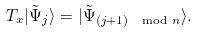Convert formula to latex. <formula><loc_0><loc_0><loc_500><loc_500>T _ { x } | \tilde { \Psi } _ { j } \rangle = | \tilde { \Psi } _ { ( j + 1 ) \mod n } \rangle .</formula> 